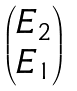<formula> <loc_0><loc_0><loc_500><loc_500>\begin{pmatrix} E _ { 2 } \\ E _ { 1 } \end{pmatrix}</formula> 